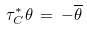Convert formula to latex. <formula><loc_0><loc_0><loc_500><loc_500>\tau _ { C } ^ { * } \theta \, = \, - \overline { \theta }</formula> 